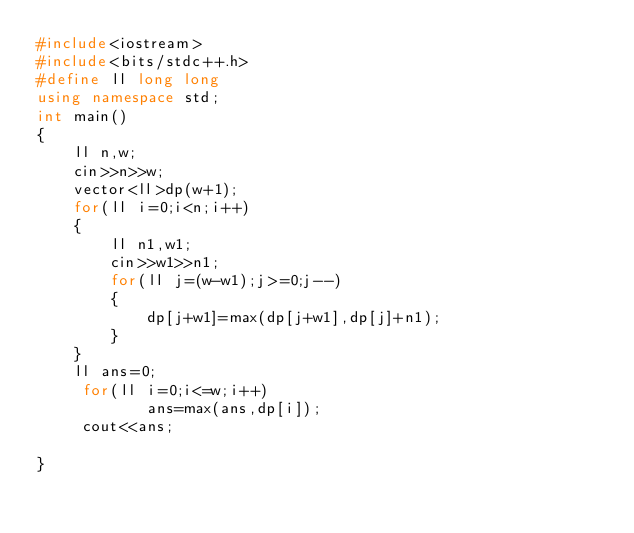Convert code to text. <code><loc_0><loc_0><loc_500><loc_500><_C++_>#include<iostream>
#include<bits/stdc++.h>
#define ll long long
using namespace std;
int main()
{
    ll n,w;
    cin>>n>>w;
    vector<ll>dp(w+1);
    for(ll i=0;i<n;i++)
    {
        ll n1,w1;
        cin>>w1>>n1;
        for(ll j=(w-w1);j>=0;j--)
        {
            dp[j+w1]=max(dp[j+w1],dp[j]+n1);
        }
    }
    ll ans=0;
     for(ll i=0;i<=w;i++)
            ans=max(ans,dp[i]);
     cout<<ans;

}
</code> 